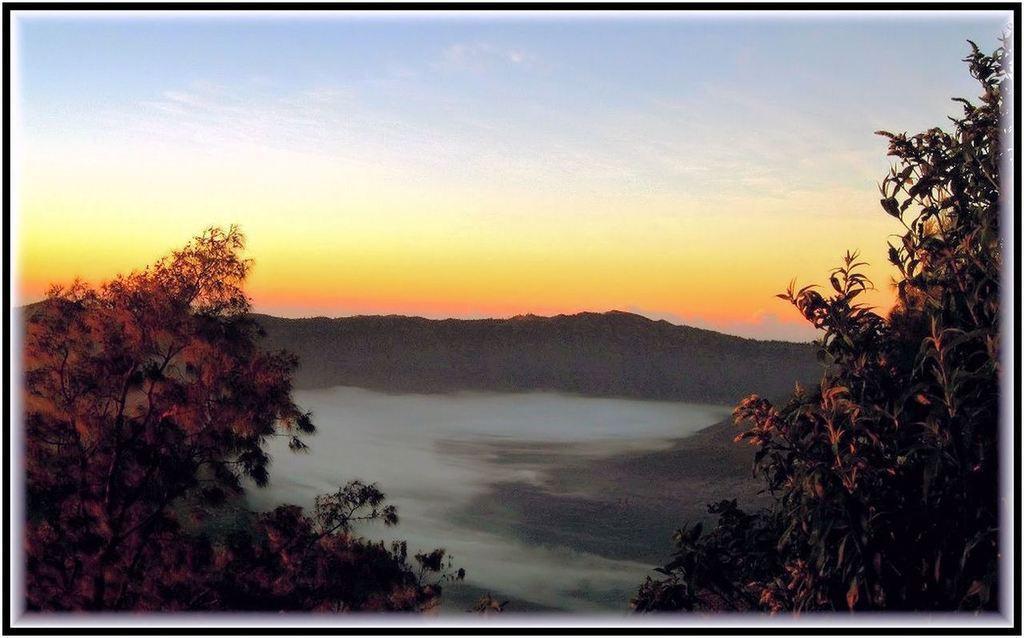Can you describe this image briefly? It is an edited image, there is a beautiful scenery with trees and mountains and in the background there is a pleasant view of the sky. 